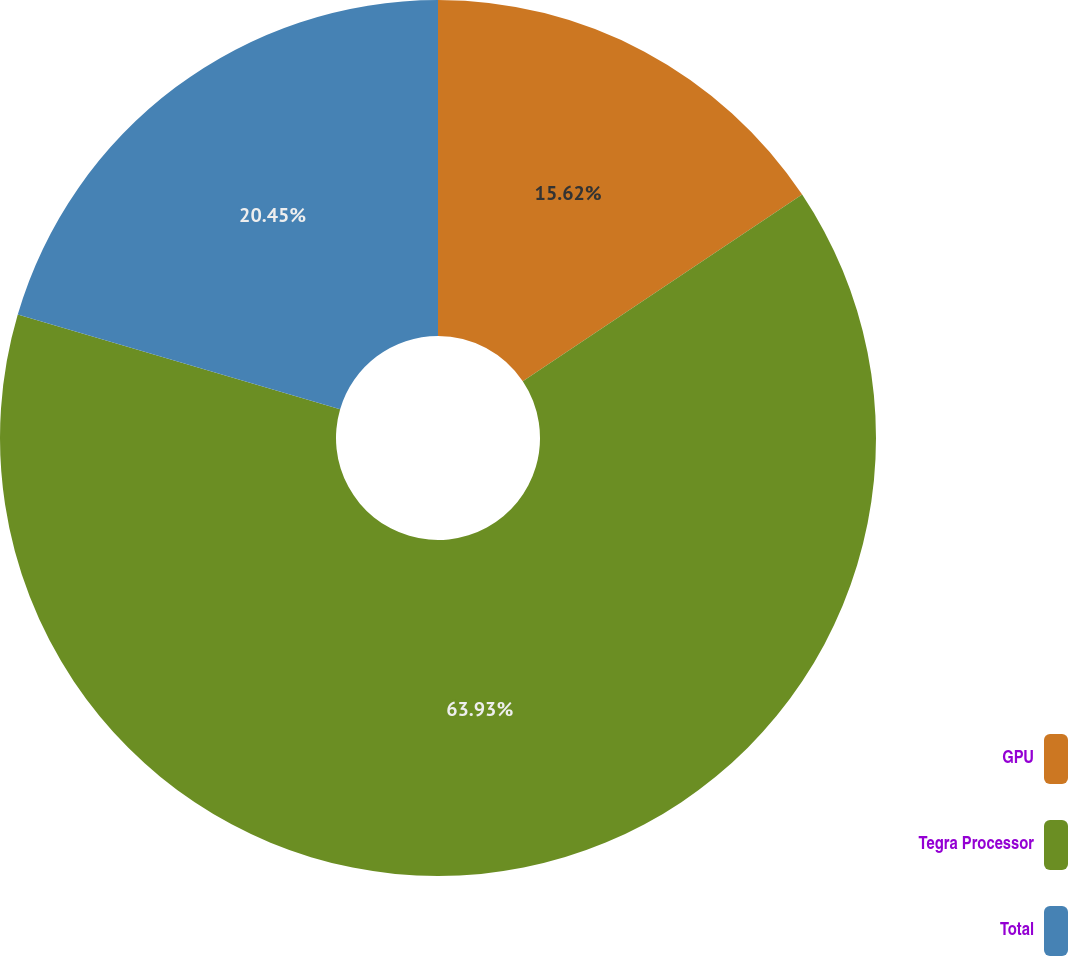Convert chart. <chart><loc_0><loc_0><loc_500><loc_500><pie_chart><fcel>GPU<fcel>Tegra Processor<fcel>Total<nl><fcel>15.62%<fcel>63.92%<fcel>20.45%<nl></chart> 